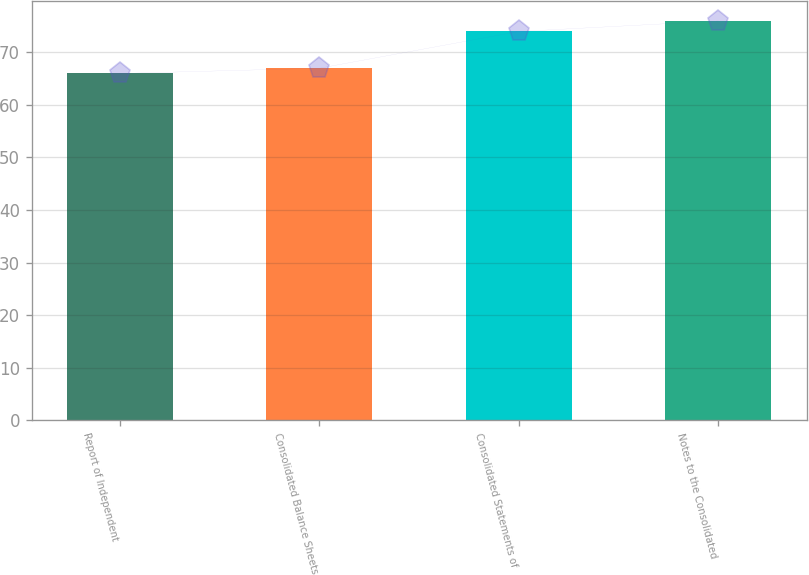Convert chart to OTSL. <chart><loc_0><loc_0><loc_500><loc_500><bar_chart><fcel>Report of Independent<fcel>Consolidated Balance Sheets<fcel>Consolidated Statements of<fcel>Notes to the Consolidated<nl><fcel>66<fcel>67<fcel>74<fcel>76<nl></chart> 